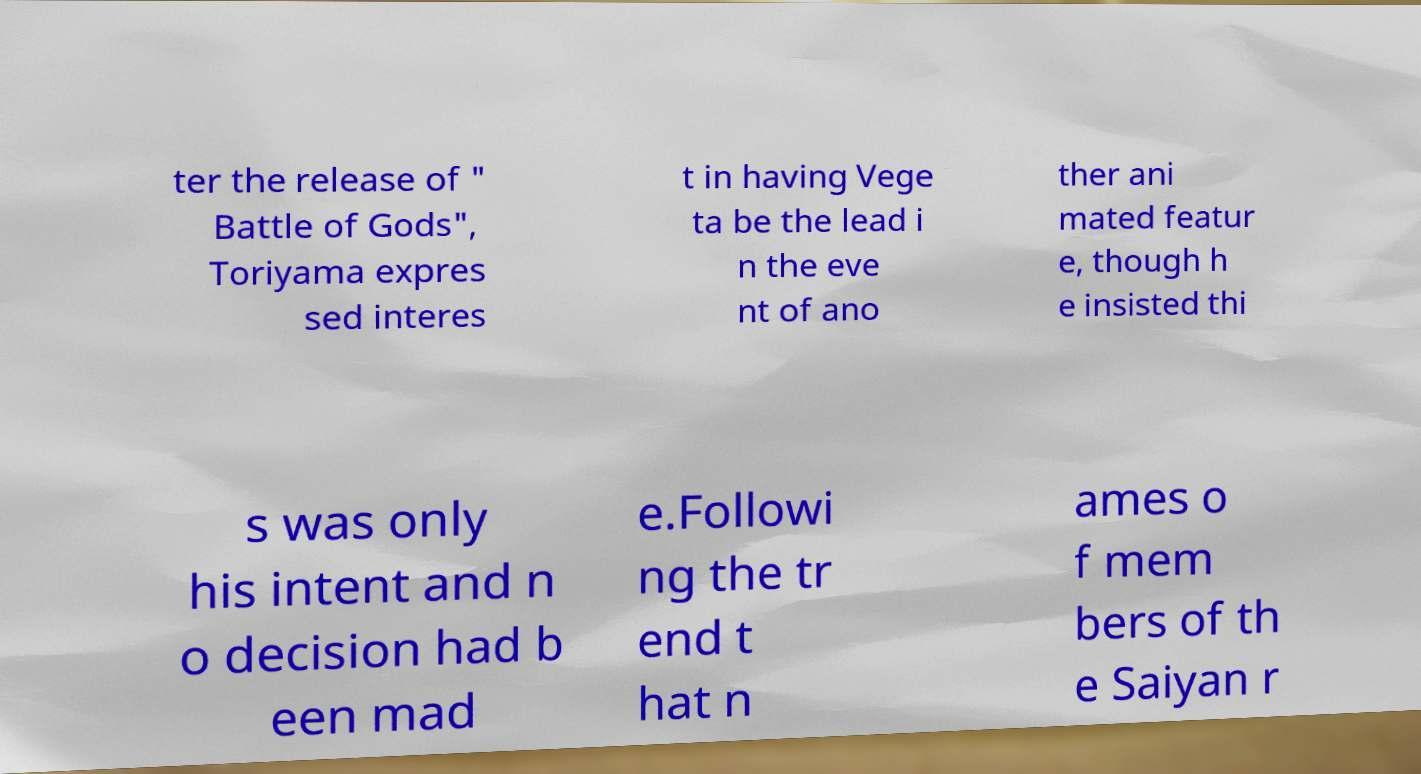I need the written content from this picture converted into text. Can you do that? ter the release of " Battle of Gods", Toriyama expres sed interes t in having Vege ta be the lead i n the eve nt of ano ther ani mated featur e, though h e insisted thi s was only his intent and n o decision had b een mad e.Followi ng the tr end t hat n ames o f mem bers of th e Saiyan r 